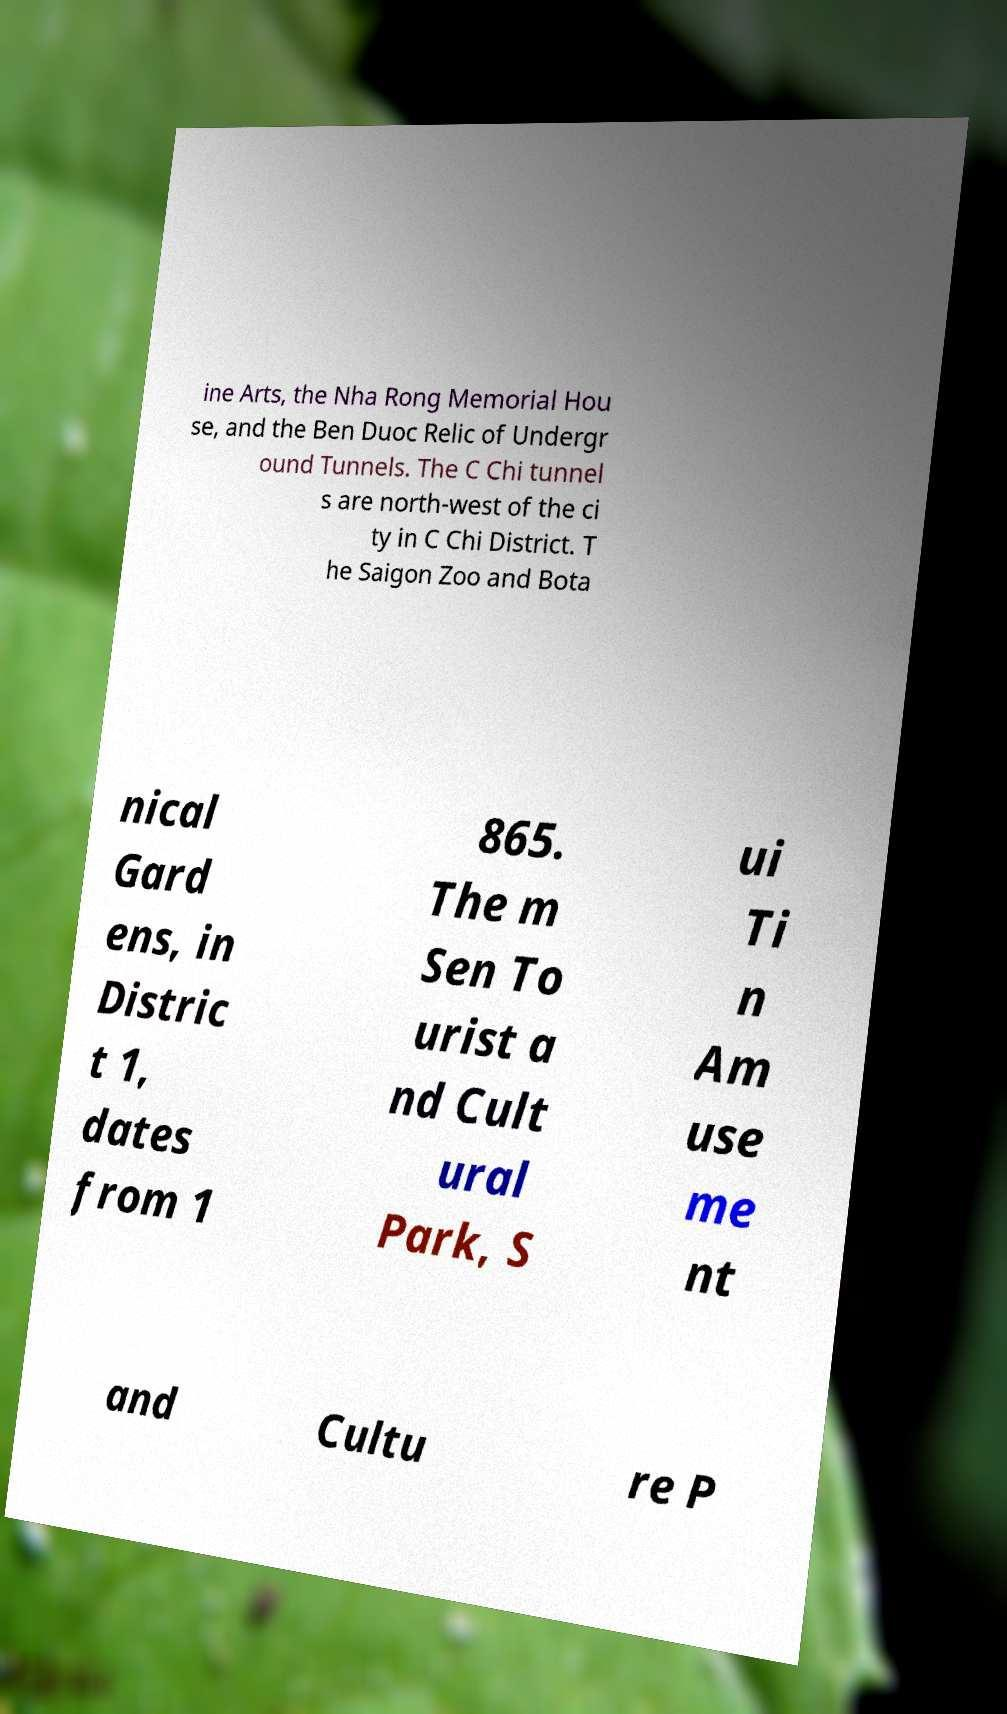Could you extract and type out the text from this image? ine Arts, the Nha Rong Memorial Hou se, and the Ben Duoc Relic of Undergr ound Tunnels. The C Chi tunnel s are north-west of the ci ty in C Chi District. T he Saigon Zoo and Bota nical Gard ens, in Distric t 1, dates from 1 865. The m Sen To urist a nd Cult ural Park, S ui Ti n Am use me nt and Cultu re P 